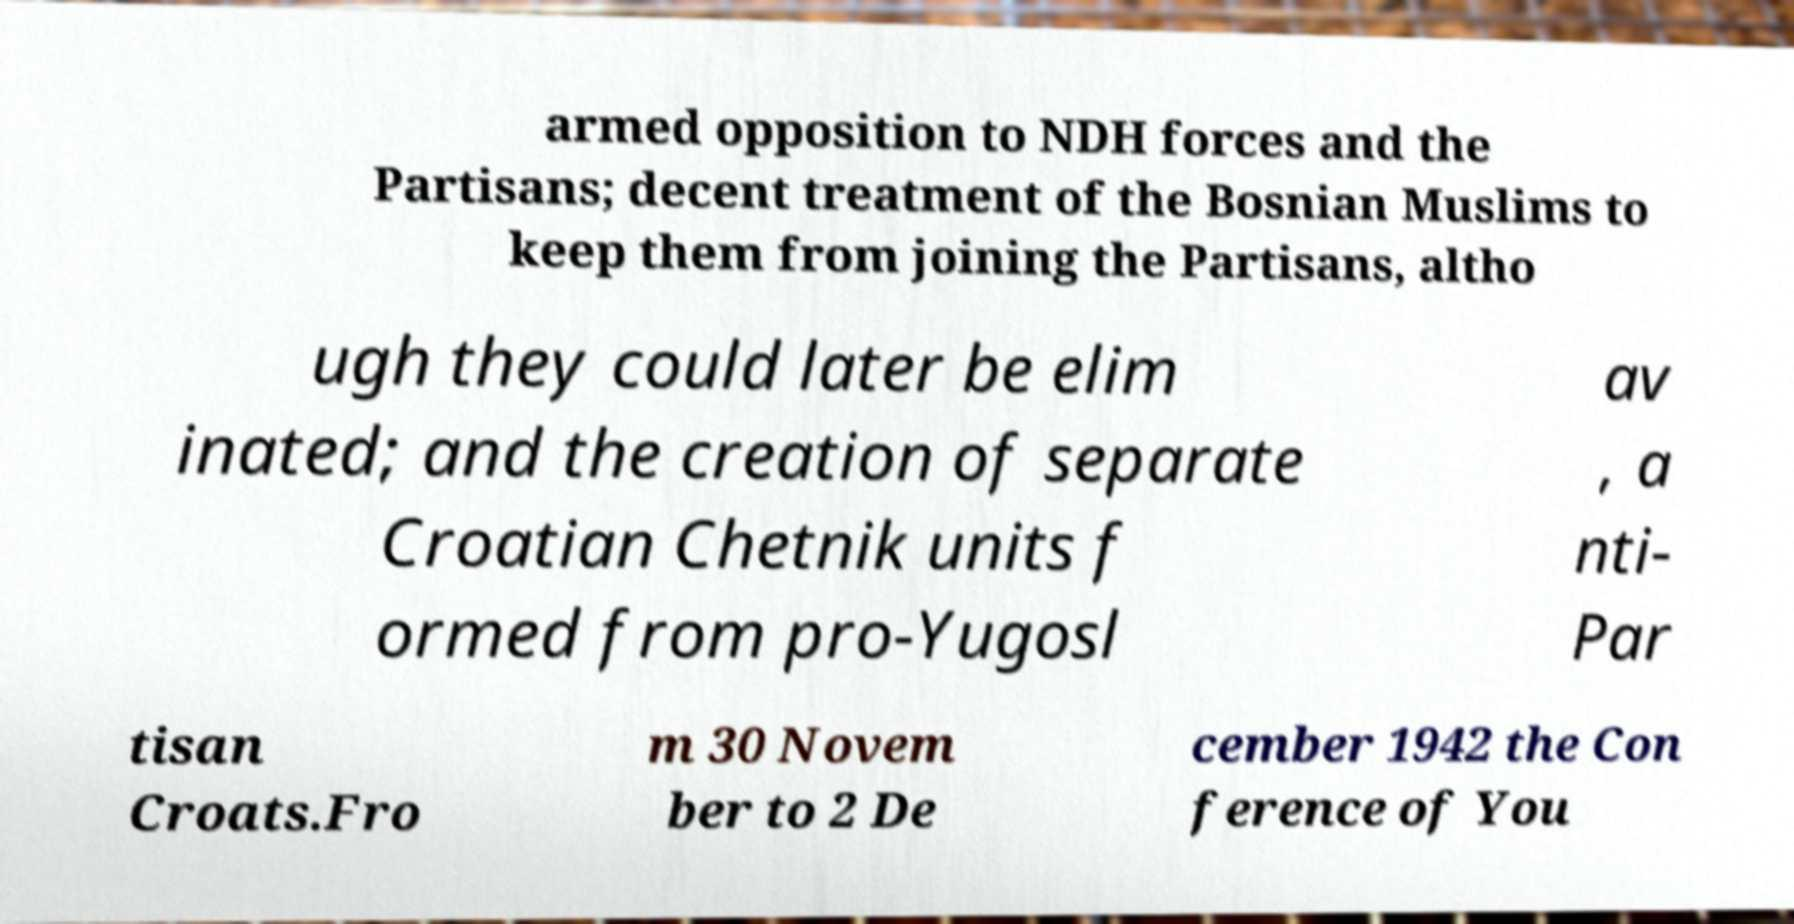There's text embedded in this image that I need extracted. Can you transcribe it verbatim? armed opposition to NDH forces and the Partisans; decent treatment of the Bosnian Muslims to keep them from joining the Partisans, altho ugh they could later be elim inated; and the creation of separate Croatian Chetnik units f ormed from pro-Yugosl av , a nti- Par tisan Croats.Fro m 30 Novem ber to 2 De cember 1942 the Con ference of You 